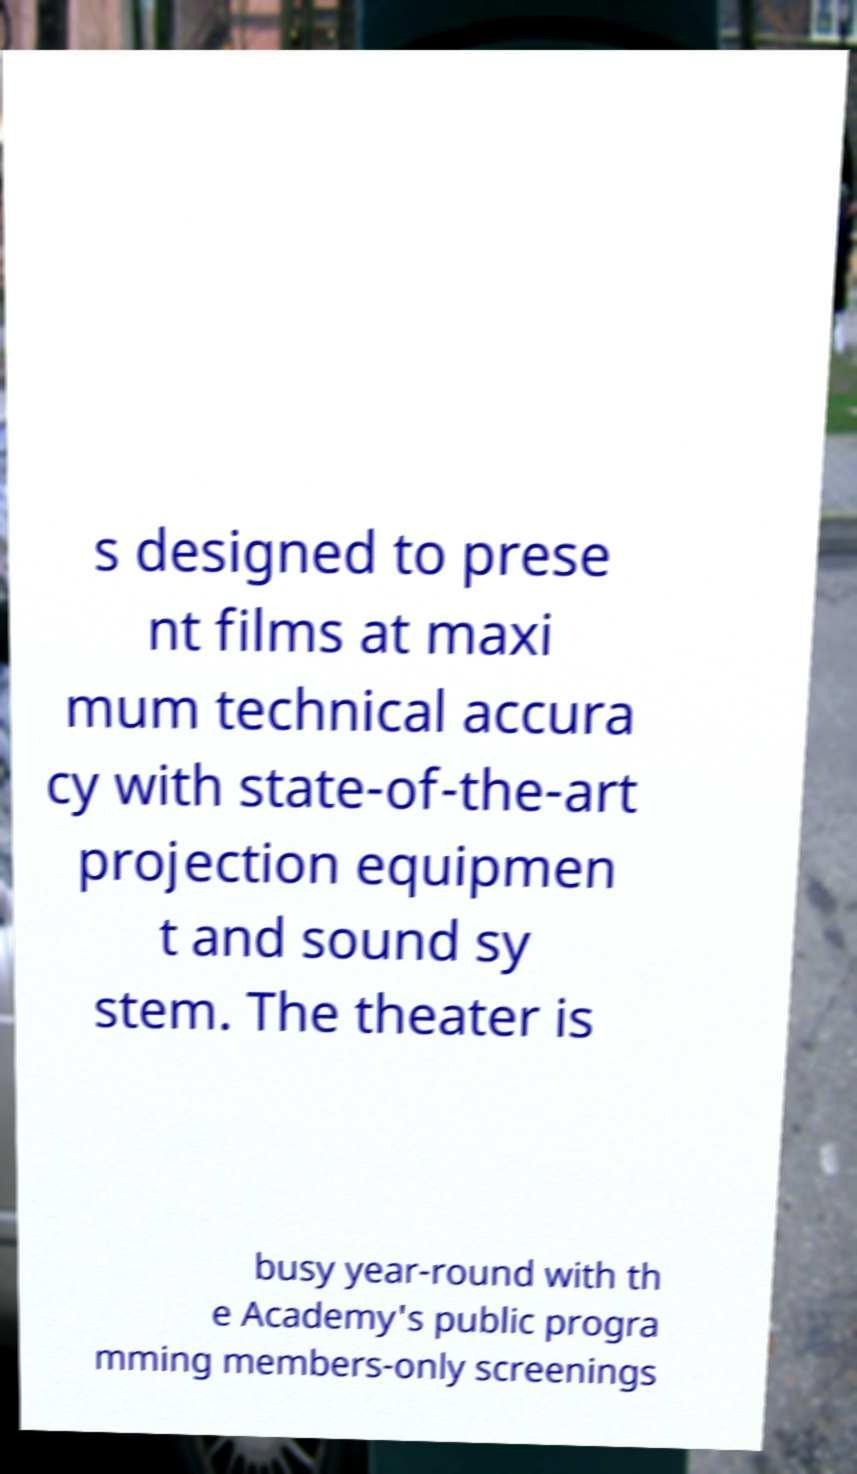Could you extract and type out the text from this image? s designed to prese nt films at maxi mum technical accura cy with state-of-the-art projection equipmen t and sound sy stem. The theater is busy year-round with th e Academy's public progra mming members-only screenings 